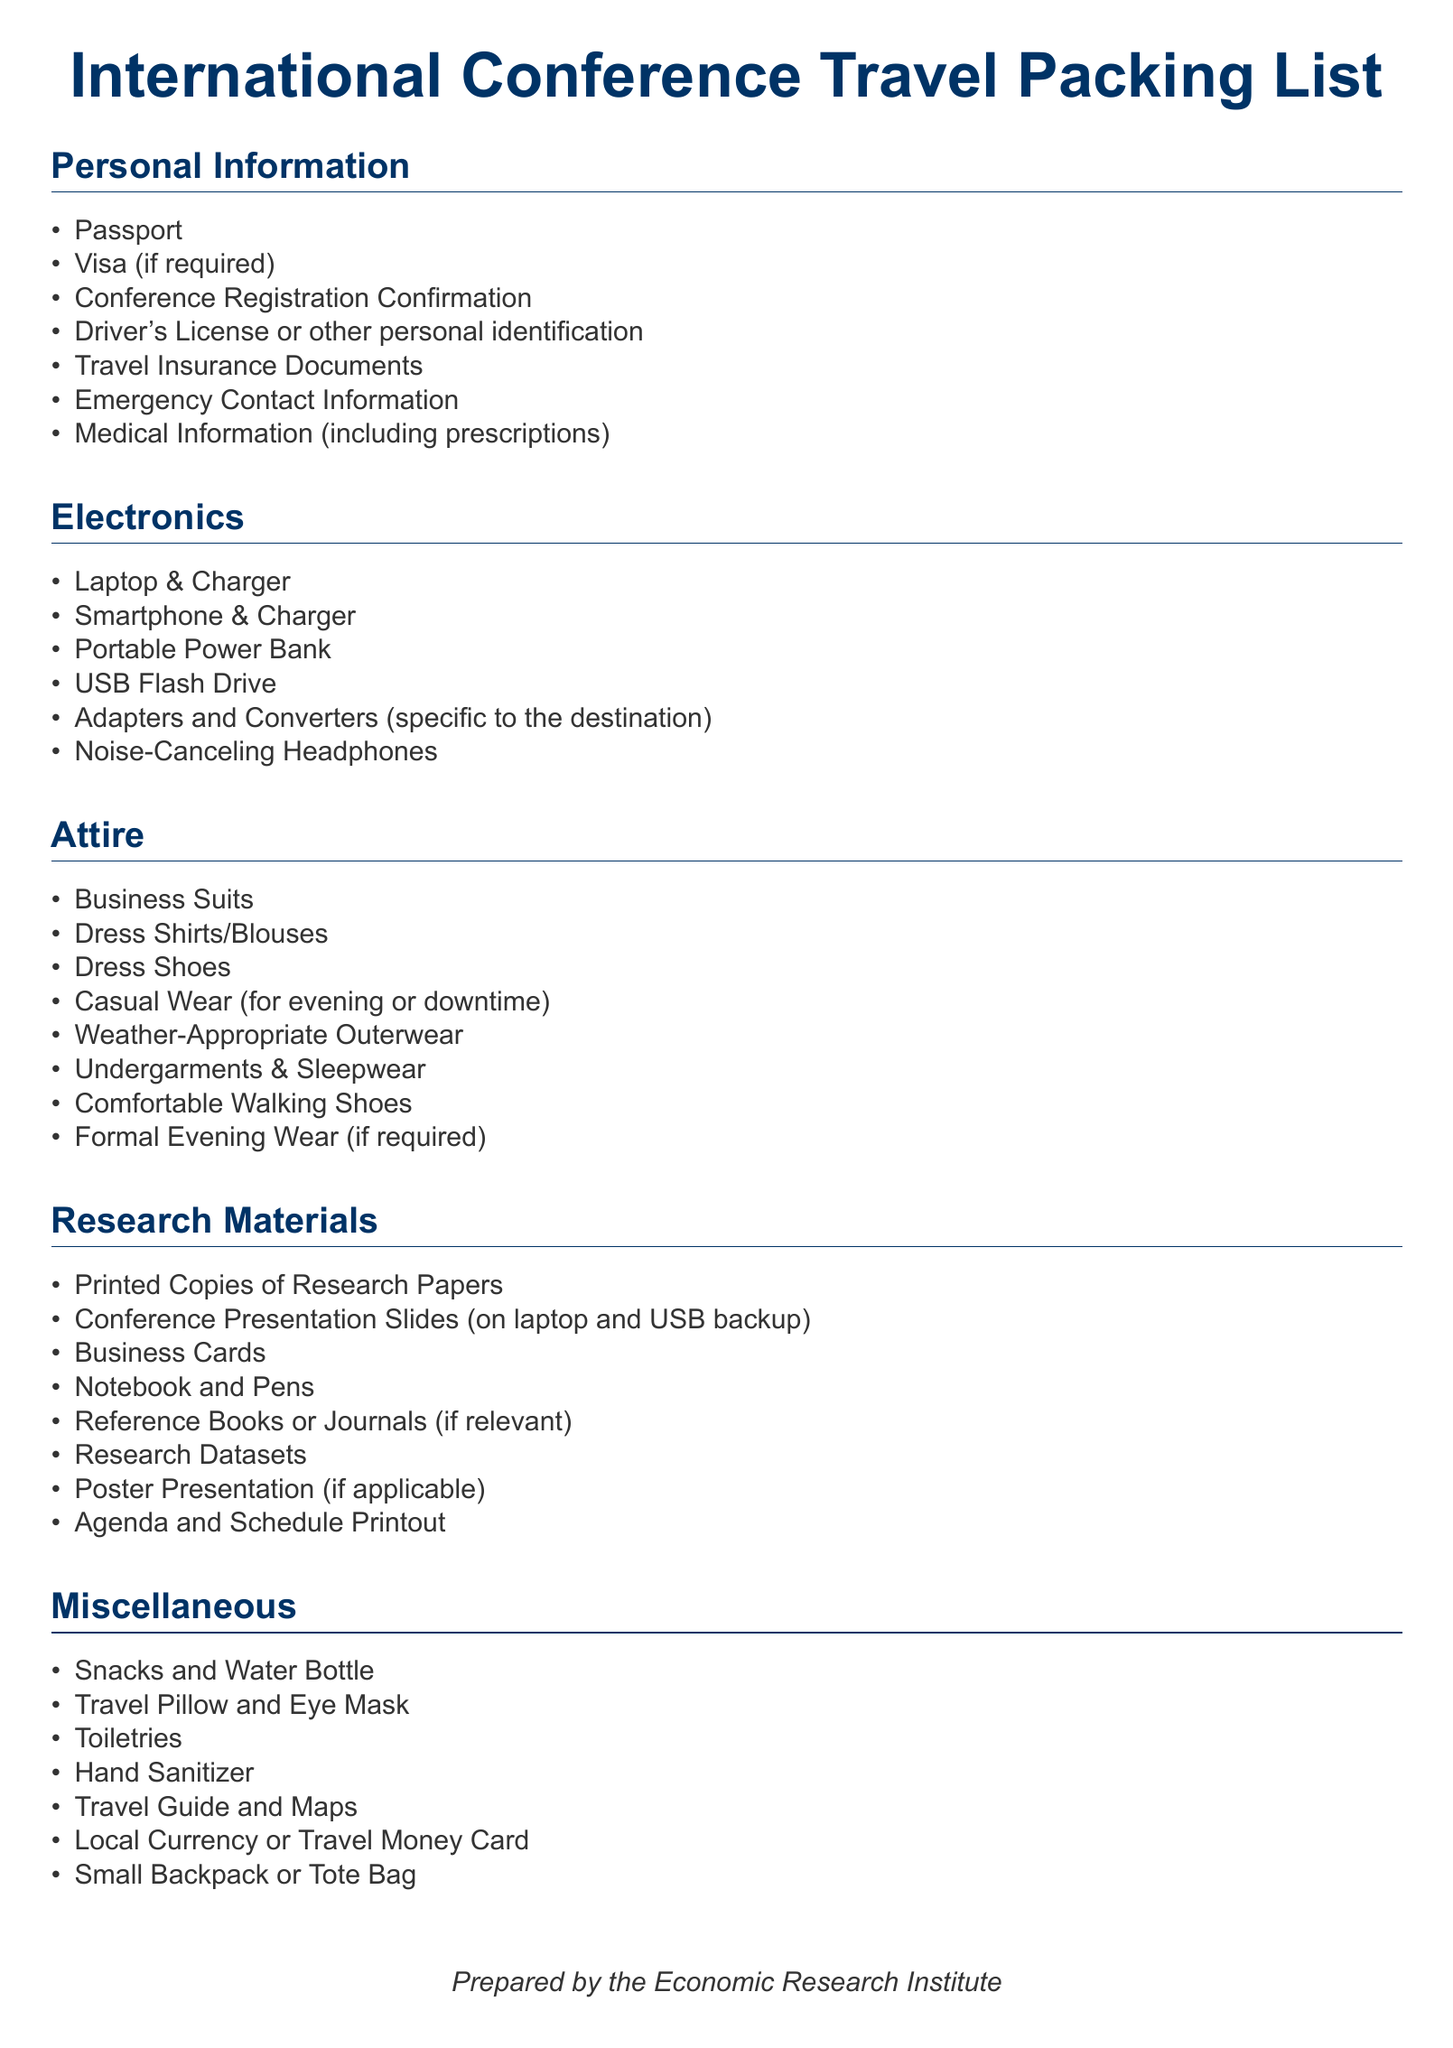What is required for personal identification? The document lists items needed for personal identification, which includes a driver's license or other personal identification.
Answer: Driver's License How many types of attire are listed? There are 8 different types of attire specified in the document under the Attire section.
Answer: 8 What electronic device is specifically mentioned for backup? The document outlines that a USB Flash Drive is included for backing up important files.
Answer: USB Flash Drive What item is recommended for keeping belongings organized during travel? The document suggests a small backpack or tote bag for organizing items while traveling.
Answer: Small Backpack or Tote Bag What type of materials should be printed for the conference? The document indicates that printed copies of research papers are necessary for the conference.
Answer: Printed Copies of Research Papers What is included in the miscellaneous section? The miscellaneous section comprises several items, including toiletries.
Answer: Toiletries What document confirms attendance at the conference? The conference registration confirmation is essential for confirming attendance as mentioned in the document.
Answer: Conference Registration Confirmation What type of shoes should be included for walking? The document specifies that comfortable walking shoes should be packed.
Answer: Comfortable Walking Shoes What electronic device is needed for noise reduction? Noise-canceling headphones are mentioned in the Electronics section for noise reduction purposes.
Answer: Noise-Canceling Headphones 